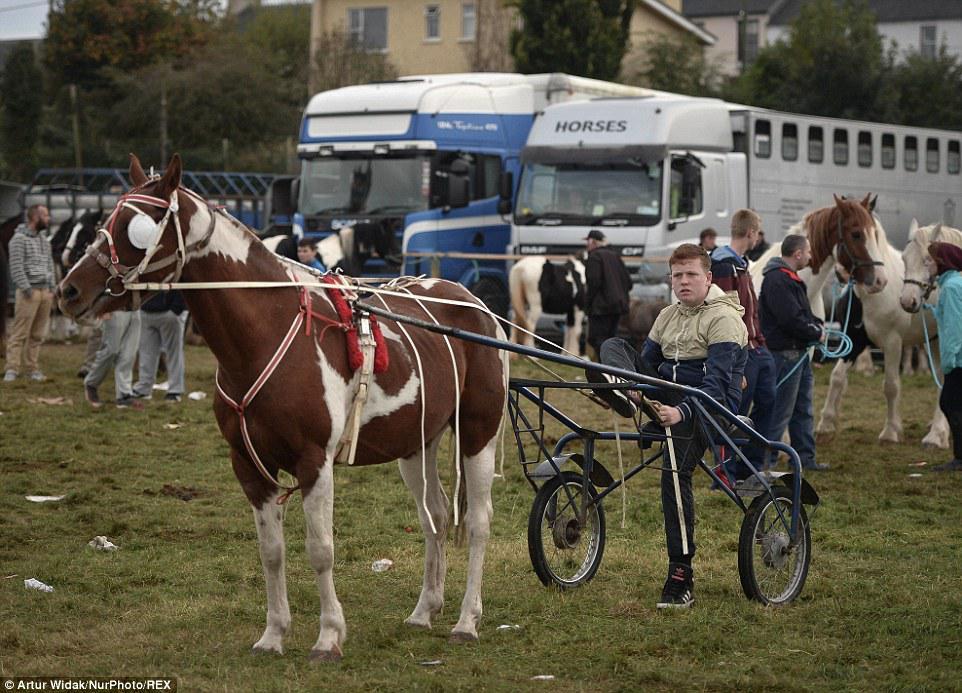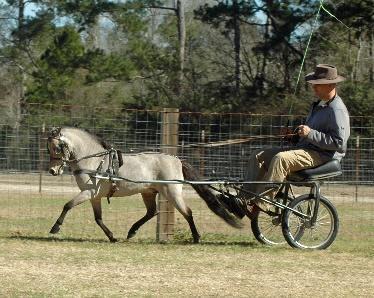The first image is the image on the left, the second image is the image on the right. For the images shown, is this caption "On each picture, there is a single horse pulling a cart." true? Answer yes or no. Yes. The first image is the image on the left, the second image is the image on the right. Given the left and right images, does the statement "An image shows a four-wheeled wagon pulled by more than one horse." hold true? Answer yes or no. No. 